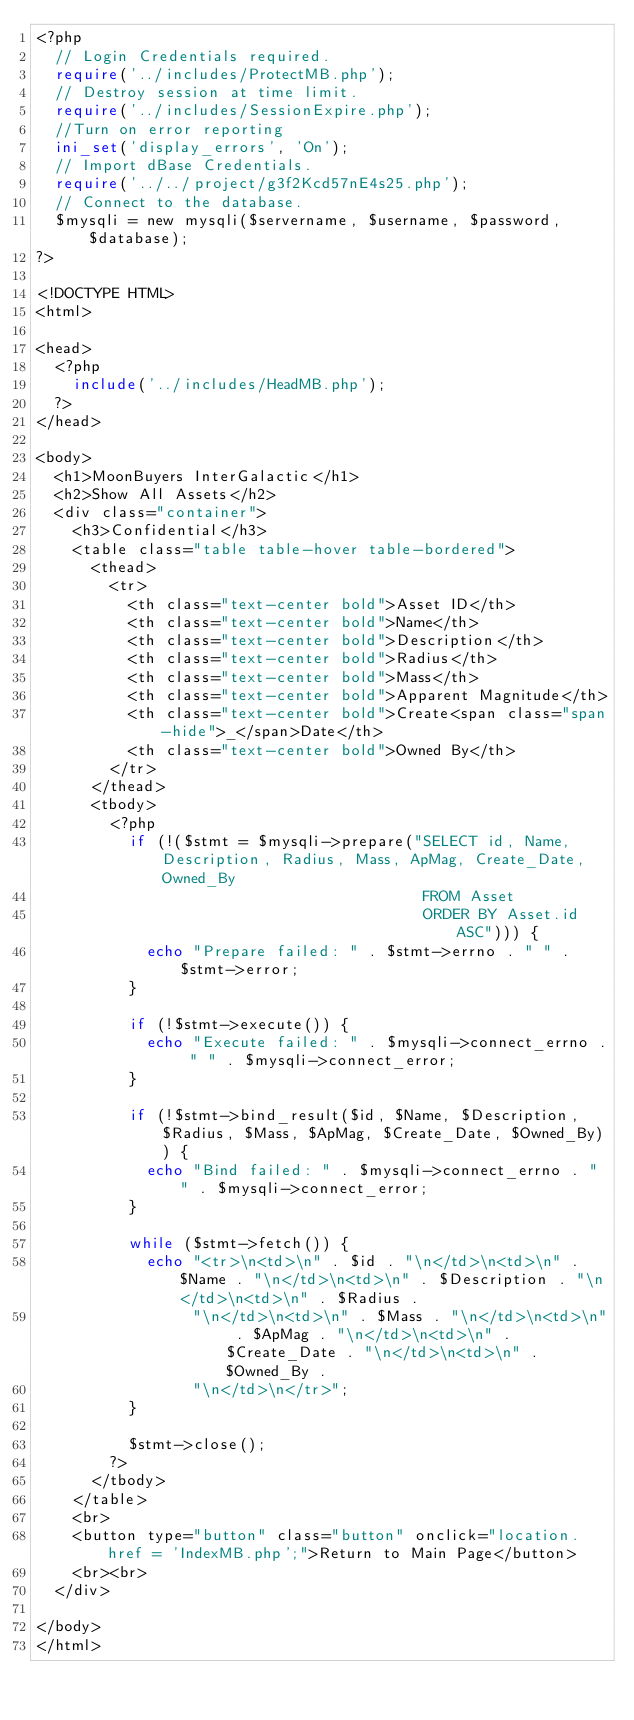Convert code to text. <code><loc_0><loc_0><loc_500><loc_500><_PHP_><?php
	// Login Credentials required.
	require('../includes/ProtectMB.php');
	// Destroy session at time limit.
	require('../includes/SessionExpire.php');
  //Turn on error reporting
  ini_set('display_errors', 'On');
  // Import dBase Credentials.
  require('../../project/g3f2Kcd57nE4s25.php');
  // Connect to the database.
  $mysqli = new mysqli($servername, $username, $password, $database);
?>

<!DOCTYPE HTML>
<html>

<head>
  <?php
    include('../includes/HeadMB.php');
  ?>
</head>

<body>
	<h1>MoonBuyers InterGalactic</h1>
	<h2>Show All Assets</h2>
	<div class="container">
		<h3>Confidential</h3>
		<table class="table table-hover table-bordered">
			<thead>
				<tr>
					<th class="text-center bold">Asset ID</th>
					<th class="text-center bold">Name</th>
					<th class="text-center bold">Description</th>
					<th class="text-center bold">Radius</th>
					<th class="text-center bold">Mass</th>
					<th class="text-center bold">Apparent Magnitude</th>
					<th class="text-center bold">Create<span class="span-hide">_</span>Date</th>
					<th class="text-center bold">Owned By</th>
				</tr>
			</thead>
			<tbody>
				<?php
					if (!($stmt = $mysqli->prepare("SELECT id, Name, Description, Radius, Mass, ApMag, Create_Date, Owned_By
																					FROM Asset
																					ORDER BY Asset.id ASC"))) {
						echo "Prepare failed: " . $stmt->errno . " " . $stmt->error;
					}

					if (!$stmt->execute()) {
						echo "Execute failed: " . $mysqli->connect_errno . " " . $mysqli->connect_error;
					}

					if (!$stmt->bind_result($id, $Name, $Description, $Radius, $Mass, $ApMag, $Create_Date, $Owned_By)) {
						echo "Bind failed: " . $mysqli->connect_errno . " " . $mysqli->connect_error;
					}

					while ($stmt->fetch()) {
						echo "<tr>\n<td>\n" . $id . "\n</td>\n<td>\n" . $Name . "\n</td>\n<td>\n" . $Description . "\n</td>\n<td>\n" . $Radius .
								 "\n</td>\n<td>\n" . $Mass . "\n</td>\n<td>\n" . $ApMag . "\n</td>\n<td>\n" . $Create_Date . "\n</td>\n<td>\n" . $Owned_By .
								 "\n</td>\n</tr>";
					}

					$stmt->close();
				?>
			</tbody>
		</table>
		<br>
    <button type="button" class="button" onclick="location.href = 'IndexMB.php';">Return to Main Page</button>
    <br><br>
	</div>

</body>
</html>
</code> 